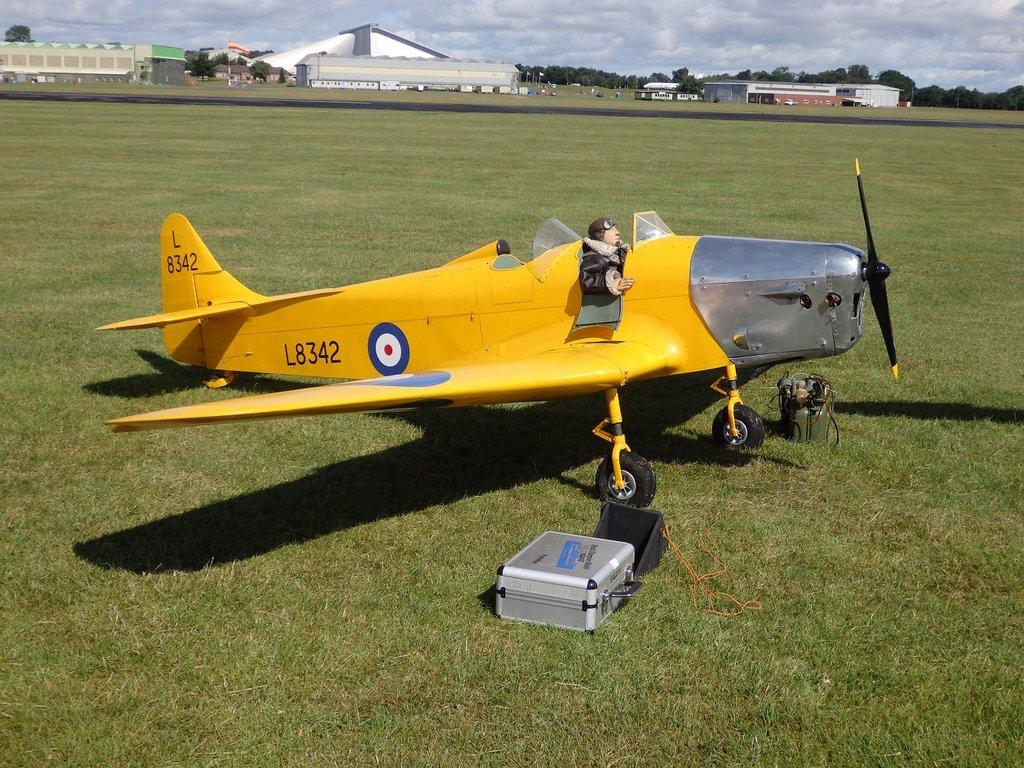What is the main subject of the image? The main subject of the image is an airplane. Can you describe the person on the airplane? Unfortunately, the image does not provide enough detail to describe the person on the airplane. What can be seen on the grass in the image? There are objects on the grass, but the image does not specify what those objects are. What is visible in the background of the image? In the background, there are buildings, flags, trees, and the sky. What type of whistle can be heard coming from the airplane in the image? There is no indication of any sound, including a whistle, in the image. What is the cause of the night sky in the image? The image does not depict a night sky; the sky is visible in the background, but it is not specified as nighttime. 